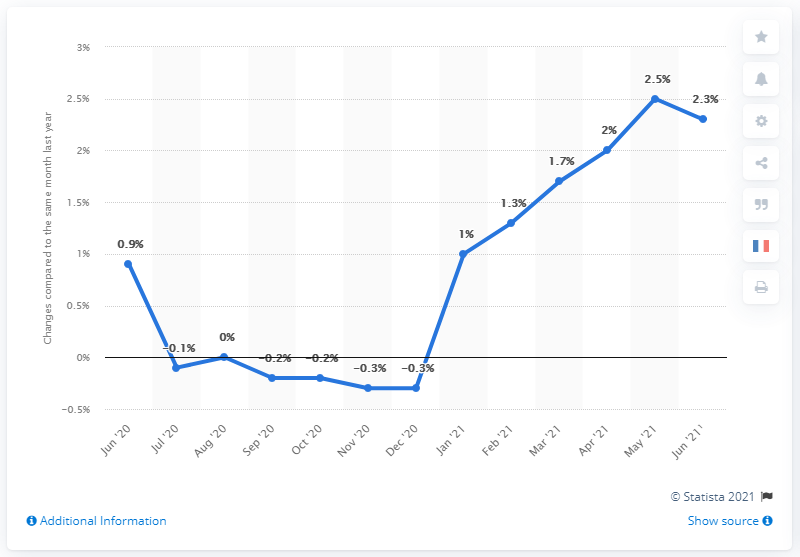Specify some key components in this picture. In June 2021, consumer prices in Germany increased by 2.3% compared to the same month of the previous year. 